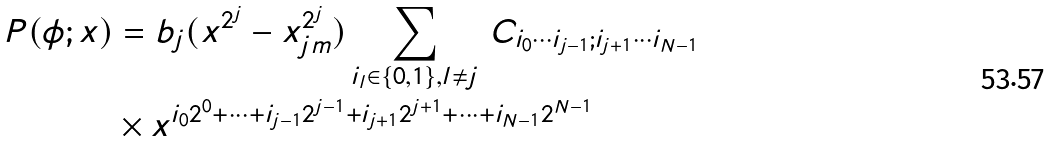Convert formula to latex. <formula><loc_0><loc_0><loc_500><loc_500>P ( \phi ; x ) & = b _ { j } ( x ^ { 2 ^ { j } } - x _ { j m } ^ { 2 ^ { j } } ) \sum _ { i _ { l } \in \{ 0 , 1 \} , l \not = j } \, C _ { i _ { 0 } \cdots i _ { j - 1 } ; i _ { j + 1 } \cdots i _ { N - 1 } } \\ & \times x ^ { i _ { 0 } 2 ^ { 0 } + \cdots + i _ { j - 1 } 2 ^ { j - 1 } + i _ { j + 1 } 2 ^ { j + 1 } + \cdots + i _ { N - 1 } 2 ^ { N - 1 } }</formula> 